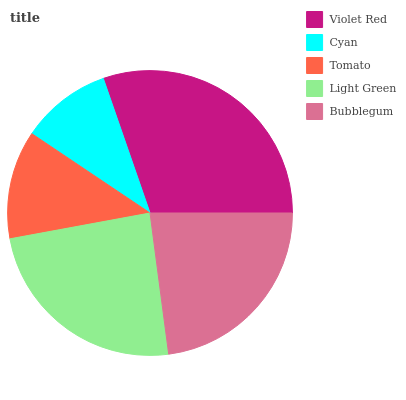Is Cyan the minimum?
Answer yes or no. Yes. Is Violet Red the maximum?
Answer yes or no. Yes. Is Tomato the minimum?
Answer yes or no. No. Is Tomato the maximum?
Answer yes or no. No. Is Tomato greater than Cyan?
Answer yes or no. Yes. Is Cyan less than Tomato?
Answer yes or no. Yes. Is Cyan greater than Tomato?
Answer yes or no. No. Is Tomato less than Cyan?
Answer yes or no. No. Is Bubblegum the high median?
Answer yes or no. Yes. Is Bubblegum the low median?
Answer yes or no. Yes. Is Light Green the high median?
Answer yes or no. No. Is Violet Red the low median?
Answer yes or no. No. 